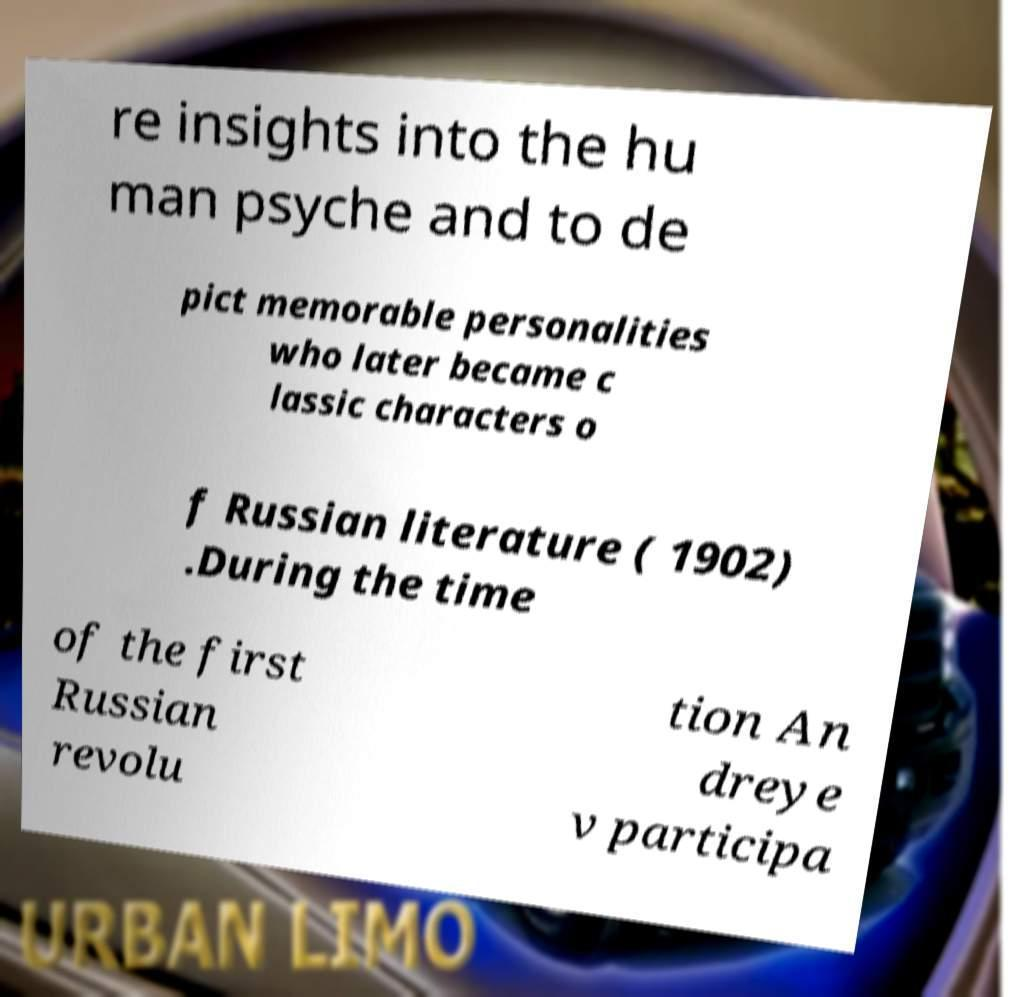Could you extract and type out the text from this image? re insights into the hu man psyche and to de pict memorable personalities who later became c lassic characters o f Russian literature ( 1902) .During the time of the first Russian revolu tion An dreye v participa 